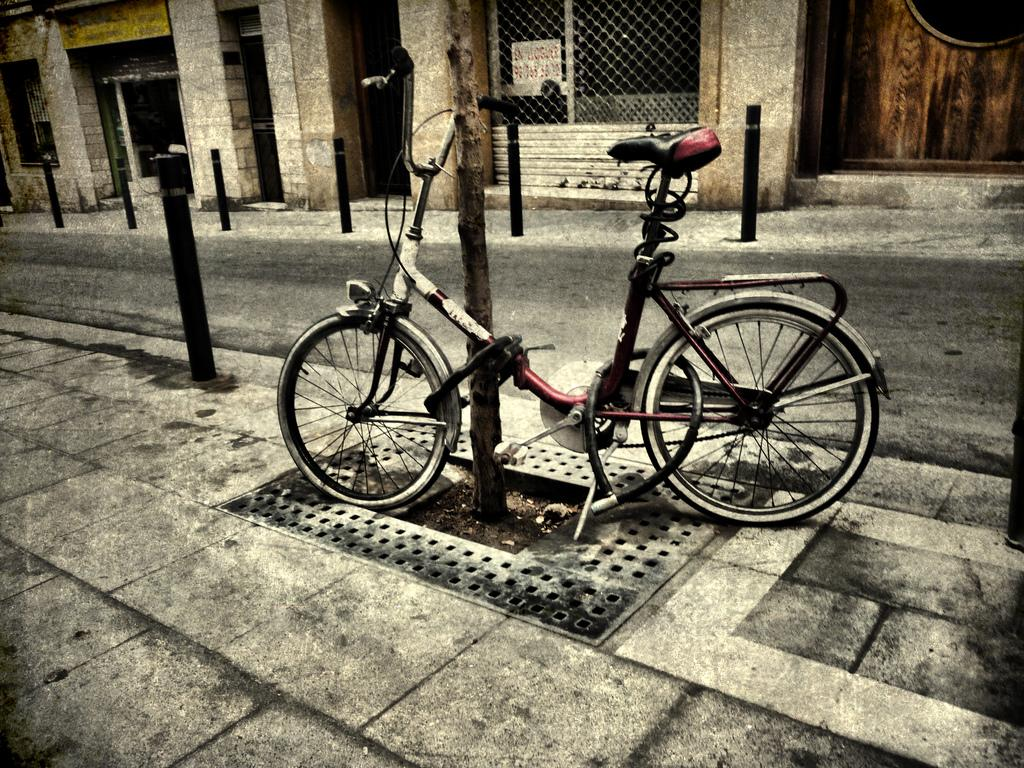What can be seen on the footpath in the image? There is a bicycle on the footpath. What is located behind the footpath? There is a road behind the footpath. What is visible on the other side of the road? There are poles and buildings visible on the other side of the road. What is the purpose of the bicycle's tongue in the image? There is no mention of a tongue in the image, as bicycles do not have tongues. 